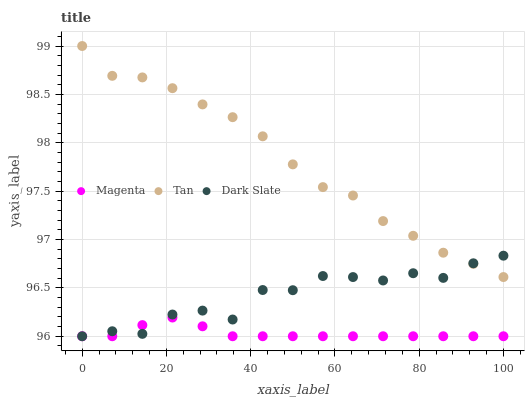Does Magenta have the minimum area under the curve?
Answer yes or no. Yes. Does Tan have the maximum area under the curve?
Answer yes or no. Yes. Does Tan have the minimum area under the curve?
Answer yes or no. No. Does Magenta have the maximum area under the curve?
Answer yes or no. No. Is Magenta the smoothest?
Answer yes or no. Yes. Is Dark Slate the roughest?
Answer yes or no. Yes. Is Tan the smoothest?
Answer yes or no. No. Is Tan the roughest?
Answer yes or no. No. Does Dark Slate have the lowest value?
Answer yes or no. Yes. Does Tan have the lowest value?
Answer yes or no. No. Does Tan have the highest value?
Answer yes or no. Yes. Does Magenta have the highest value?
Answer yes or no. No. Is Magenta less than Tan?
Answer yes or no. Yes. Is Tan greater than Magenta?
Answer yes or no. Yes. Does Dark Slate intersect Tan?
Answer yes or no. Yes. Is Dark Slate less than Tan?
Answer yes or no. No. Is Dark Slate greater than Tan?
Answer yes or no. No. Does Magenta intersect Tan?
Answer yes or no. No. 